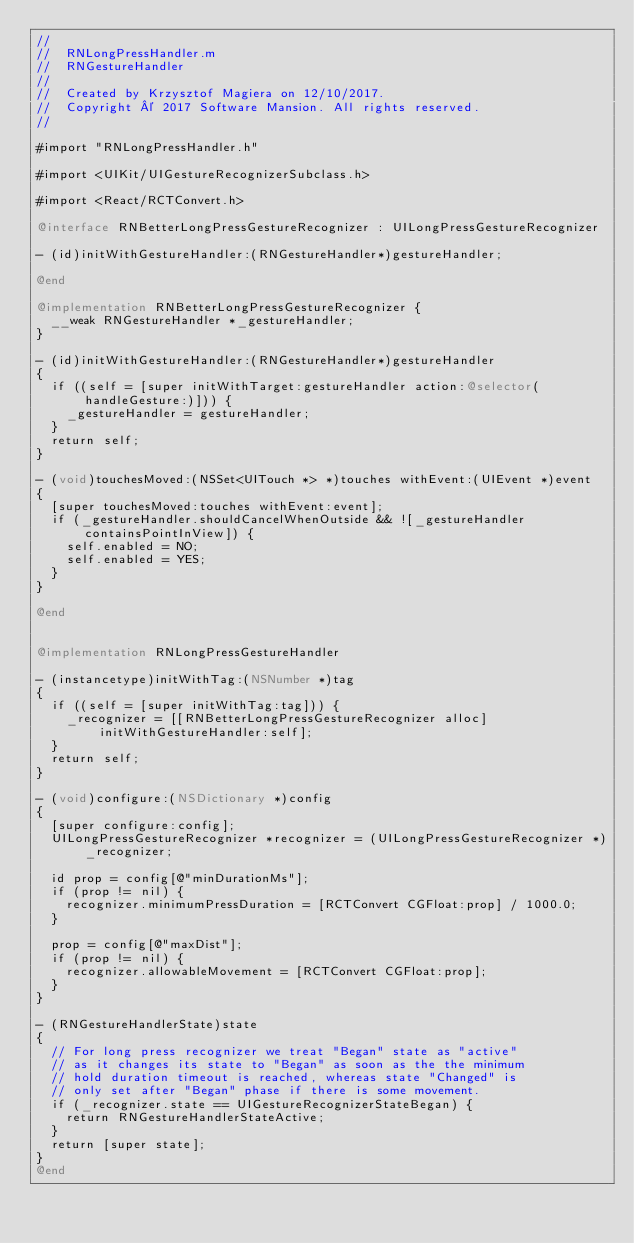Convert code to text. <code><loc_0><loc_0><loc_500><loc_500><_ObjectiveC_>//
//  RNLongPressHandler.m
//  RNGestureHandler
//
//  Created by Krzysztof Magiera on 12/10/2017.
//  Copyright © 2017 Software Mansion. All rights reserved.
//

#import "RNLongPressHandler.h"

#import <UIKit/UIGestureRecognizerSubclass.h>

#import <React/RCTConvert.h>

@interface RNBetterLongPressGestureRecognizer : UILongPressGestureRecognizer

- (id)initWithGestureHandler:(RNGestureHandler*)gestureHandler;

@end

@implementation RNBetterLongPressGestureRecognizer {
  __weak RNGestureHandler *_gestureHandler;
}

- (id)initWithGestureHandler:(RNGestureHandler*)gestureHandler
{
  if ((self = [super initWithTarget:gestureHandler action:@selector(handleGesture:)])) {
    _gestureHandler = gestureHandler;
  }
  return self;
}

- (void)touchesMoved:(NSSet<UITouch *> *)touches withEvent:(UIEvent *)event
{
  [super touchesMoved:touches withEvent:event];
  if (_gestureHandler.shouldCancelWhenOutside && ![_gestureHandler containsPointInView]) {
    self.enabled = NO;
    self.enabled = YES;
  }
}

@end


@implementation RNLongPressGestureHandler

- (instancetype)initWithTag:(NSNumber *)tag
{
  if ((self = [super initWithTag:tag])) {
    _recognizer = [[RNBetterLongPressGestureRecognizer alloc] initWithGestureHandler:self];
  }
  return self;
}

- (void)configure:(NSDictionary *)config
{
  [super configure:config];
  UILongPressGestureRecognizer *recognizer = (UILongPressGestureRecognizer *)_recognizer;
  
  id prop = config[@"minDurationMs"];
  if (prop != nil) {
    recognizer.minimumPressDuration = [RCTConvert CGFloat:prop] / 1000.0;
  }
  
  prop = config[@"maxDist"];
  if (prop != nil) {
    recognizer.allowableMovement = [RCTConvert CGFloat:prop];
  }
}

- (RNGestureHandlerState)state
{
  // For long press recognizer we treat "Began" state as "active"
  // as it changes its state to "Began" as soon as the the minimum
  // hold duration timeout is reached, whereas state "Changed" is
  // only set after "Began" phase if there is some movement.
  if (_recognizer.state == UIGestureRecognizerStateBegan) {
    return RNGestureHandlerStateActive;
  }
  return [super state];
}
@end

</code> 